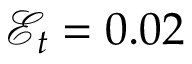<formula> <loc_0><loc_0><loc_500><loc_500>\mathcal { E } _ { t } = 0 . 0 2</formula> 